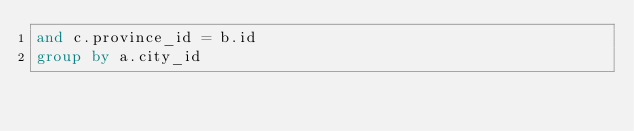Convert code to text. <code><loc_0><loc_0><loc_500><loc_500><_SQL_>and c.province_id = b.id
group by a.city_id</code> 